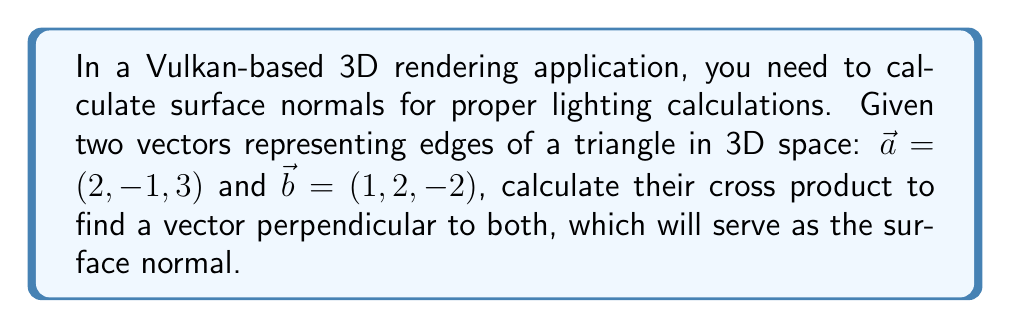What is the answer to this math problem? To calculate the cross product of two vectors $\vec{a} = (a_x, a_y, a_z)$ and $\vec{b} = (b_x, b_y, b_z)$, we use the formula:

$$\vec{a} \times \vec{b} = (a_y b_z - a_z b_y, a_z b_x - a_x b_z, a_x b_y - a_y b_x)$$

Given:
$\vec{a} = (2, -1, 3)$
$\vec{b} = (1, 2, -2)$

Let's calculate each component:

1. x-component: $a_y b_z - a_z b_y = (-1)(-2) - (3)(2) = 2 - 6 = -4$

2. y-component: $a_z b_x - a_x b_z = (3)(1) - (2)(-2) = 3 + 4 = 7$

3. z-component: $a_x b_y - a_y b_x = (2)(2) - (-1)(1) = 4 + 1 = 5$

Therefore, the cross product $\vec{a} \times \vec{b} = (-4, 7, 5)$. This vector is perpendicular to both $\vec{a}$ and $\vec{b}$ and can be used as the surface normal for the triangle in the Vulkan rendering application.

Note: In Vulkan, you may need to normalize this vector depending on your specific shading requirements.
Answer: $\vec{a} \times \vec{b} = (-4, 7, 5)$ 